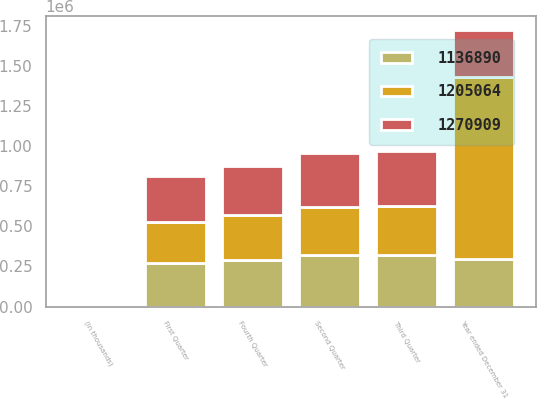Convert chart to OTSL. <chart><loc_0><loc_0><loc_500><loc_500><stacked_bar_chart><ecel><fcel>(in thousands)<fcel>First Quarter<fcel>Second Quarter<fcel>Third Quarter<fcel>Fourth Quarter<fcel>Year ended December 31<nl><fcel>1.27091e+06<fcel>2012<fcel>289465<fcel>334872<fcel>340179<fcel>306393<fcel>294134<nl><fcel>1.13689e+06<fcel>2011<fcel>271643<fcel>320436<fcel>323929<fcel>289056<fcel>294134<nl><fcel>1.20506e+06<fcel>2010<fcel>253041<fcel>298803<fcel>305118<fcel>279928<fcel>1.13689e+06<nl></chart> 